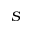<formula> <loc_0><loc_0><loc_500><loc_500>S</formula> 